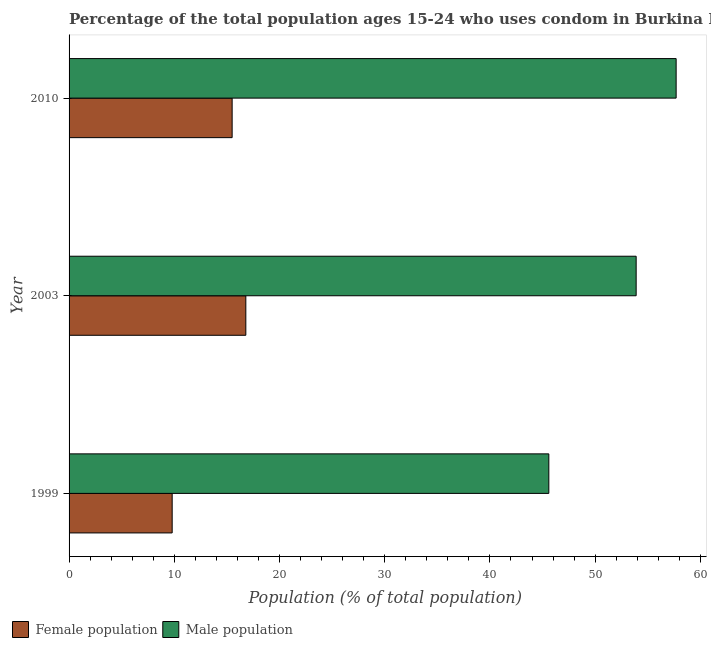How many different coloured bars are there?
Your response must be concise. 2. How many groups of bars are there?
Your answer should be compact. 3. Are the number of bars on each tick of the Y-axis equal?
Your answer should be very brief. Yes. How many bars are there on the 1st tick from the bottom?
Your answer should be compact. 2. What is the label of the 2nd group of bars from the top?
Your answer should be compact. 2003. In how many cases, is the number of bars for a given year not equal to the number of legend labels?
Give a very brief answer. 0. What is the male population in 2010?
Offer a terse response. 57.7. Across all years, what is the maximum female population?
Your response must be concise. 16.8. Across all years, what is the minimum female population?
Offer a very short reply. 9.8. What is the total female population in the graph?
Ensure brevity in your answer.  42.1. What is the difference between the male population in 2010 and the female population in 1999?
Your answer should be very brief. 47.9. What is the average female population per year?
Ensure brevity in your answer.  14.03. In the year 2010, what is the difference between the male population and female population?
Keep it short and to the point. 42.2. What is the ratio of the male population in 1999 to that in 2003?
Provide a short and direct response. 0.85. Is the female population in 1999 less than that in 2003?
Ensure brevity in your answer.  Yes. Is the difference between the female population in 1999 and 2003 greater than the difference between the male population in 1999 and 2003?
Your response must be concise. Yes. What is the difference between the highest and the lowest male population?
Offer a very short reply. 12.1. Is the sum of the female population in 2003 and 2010 greater than the maximum male population across all years?
Ensure brevity in your answer.  No. What does the 1st bar from the top in 2010 represents?
Your answer should be very brief. Male population. What does the 1st bar from the bottom in 2010 represents?
Your answer should be very brief. Female population. How many bars are there?
Offer a terse response. 6. How many years are there in the graph?
Provide a succinct answer. 3. What is the difference between two consecutive major ticks on the X-axis?
Your response must be concise. 10. Does the graph contain grids?
Offer a very short reply. No. Where does the legend appear in the graph?
Your answer should be very brief. Bottom left. How many legend labels are there?
Give a very brief answer. 2. What is the title of the graph?
Make the answer very short. Percentage of the total population ages 15-24 who uses condom in Burkina Faso. What is the label or title of the X-axis?
Provide a succinct answer. Population (% of total population) . What is the label or title of the Y-axis?
Your answer should be compact. Year. What is the Population (% of total population)  in Male population in 1999?
Your answer should be compact. 45.6. What is the Population (% of total population)  in Male population in 2003?
Make the answer very short. 53.9. What is the Population (% of total population)  of Male population in 2010?
Your answer should be very brief. 57.7. Across all years, what is the maximum Population (% of total population)  of Male population?
Offer a very short reply. 57.7. Across all years, what is the minimum Population (% of total population)  of Male population?
Offer a very short reply. 45.6. What is the total Population (% of total population)  in Female population in the graph?
Your answer should be very brief. 42.1. What is the total Population (% of total population)  of Male population in the graph?
Ensure brevity in your answer.  157.2. What is the difference between the Population (% of total population)  of Male population in 1999 and that in 2003?
Keep it short and to the point. -8.3. What is the difference between the Population (% of total population)  in Female population in 1999 and that in 2010?
Provide a succinct answer. -5.7. What is the difference between the Population (% of total population)  in Female population in 1999 and the Population (% of total population)  in Male population in 2003?
Keep it short and to the point. -44.1. What is the difference between the Population (% of total population)  in Female population in 1999 and the Population (% of total population)  in Male population in 2010?
Ensure brevity in your answer.  -47.9. What is the difference between the Population (% of total population)  in Female population in 2003 and the Population (% of total population)  in Male population in 2010?
Keep it short and to the point. -40.9. What is the average Population (% of total population)  of Female population per year?
Offer a terse response. 14.03. What is the average Population (% of total population)  in Male population per year?
Your answer should be very brief. 52.4. In the year 1999, what is the difference between the Population (% of total population)  of Female population and Population (% of total population)  of Male population?
Offer a terse response. -35.8. In the year 2003, what is the difference between the Population (% of total population)  of Female population and Population (% of total population)  of Male population?
Keep it short and to the point. -37.1. In the year 2010, what is the difference between the Population (% of total population)  in Female population and Population (% of total population)  in Male population?
Offer a very short reply. -42.2. What is the ratio of the Population (% of total population)  in Female population in 1999 to that in 2003?
Your response must be concise. 0.58. What is the ratio of the Population (% of total population)  of Male population in 1999 to that in 2003?
Ensure brevity in your answer.  0.85. What is the ratio of the Population (% of total population)  in Female population in 1999 to that in 2010?
Keep it short and to the point. 0.63. What is the ratio of the Population (% of total population)  of Male population in 1999 to that in 2010?
Ensure brevity in your answer.  0.79. What is the ratio of the Population (% of total population)  in Female population in 2003 to that in 2010?
Your answer should be very brief. 1.08. What is the ratio of the Population (% of total population)  of Male population in 2003 to that in 2010?
Your answer should be compact. 0.93. What is the difference between the highest and the second highest Population (% of total population)  of Male population?
Your response must be concise. 3.8. What is the difference between the highest and the lowest Population (% of total population)  of Female population?
Your answer should be compact. 7. What is the difference between the highest and the lowest Population (% of total population)  in Male population?
Your answer should be compact. 12.1. 